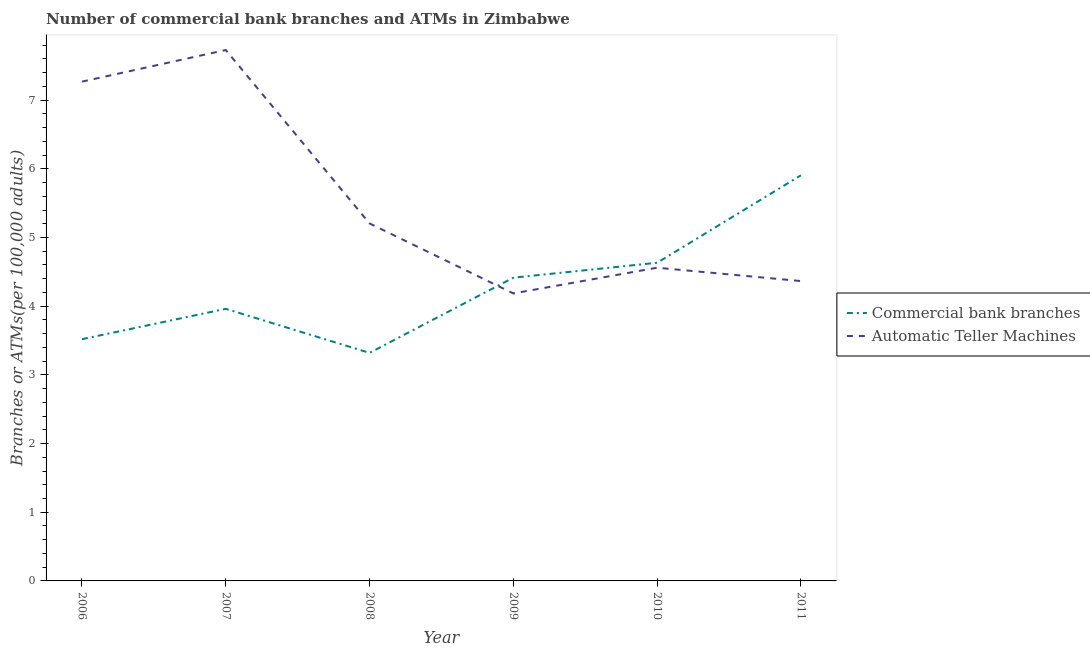How many different coloured lines are there?
Give a very brief answer. 2. Is the number of lines equal to the number of legend labels?
Your answer should be compact. Yes. What is the number of atms in 2009?
Make the answer very short. 4.19. Across all years, what is the maximum number of atms?
Give a very brief answer. 7.73. Across all years, what is the minimum number of commercal bank branches?
Make the answer very short. 3.32. In which year was the number of atms minimum?
Your response must be concise. 2009. What is the total number of commercal bank branches in the graph?
Give a very brief answer. 25.75. What is the difference between the number of atms in 2007 and that in 2011?
Make the answer very short. 3.36. What is the difference between the number of atms in 2011 and the number of commercal bank branches in 2008?
Offer a terse response. 1.05. What is the average number of atms per year?
Provide a short and direct response. 5.55. In the year 2009, what is the difference between the number of commercal bank branches and number of atms?
Keep it short and to the point. 0.23. In how many years, is the number of commercal bank branches greater than 3.8?
Make the answer very short. 4. What is the ratio of the number of atms in 2006 to that in 2008?
Provide a succinct answer. 1.4. Is the number of commercal bank branches in 2008 less than that in 2009?
Offer a terse response. Yes. Is the difference between the number of atms in 2006 and 2011 greater than the difference between the number of commercal bank branches in 2006 and 2011?
Keep it short and to the point. Yes. What is the difference between the highest and the second highest number of atms?
Make the answer very short. 0.46. What is the difference between the highest and the lowest number of commercal bank branches?
Ensure brevity in your answer.  2.59. In how many years, is the number of atms greater than the average number of atms taken over all years?
Make the answer very short. 2. Is the sum of the number of commercal bank branches in 2009 and 2010 greater than the maximum number of atms across all years?
Offer a very short reply. Yes. Does the number of commercal bank branches monotonically increase over the years?
Make the answer very short. No. Is the number of commercal bank branches strictly greater than the number of atms over the years?
Offer a very short reply. No. Is the number of atms strictly less than the number of commercal bank branches over the years?
Offer a very short reply. No. How many years are there in the graph?
Give a very brief answer. 6. What is the difference between two consecutive major ticks on the Y-axis?
Ensure brevity in your answer.  1. Does the graph contain grids?
Your answer should be compact. No. Where does the legend appear in the graph?
Your answer should be very brief. Center right. How many legend labels are there?
Keep it short and to the point. 2. What is the title of the graph?
Your answer should be compact. Number of commercial bank branches and ATMs in Zimbabwe. What is the label or title of the X-axis?
Your answer should be very brief. Year. What is the label or title of the Y-axis?
Your answer should be compact. Branches or ATMs(per 100,0 adults). What is the Branches or ATMs(per 100,000 adults) of Commercial bank branches in 2006?
Ensure brevity in your answer.  3.52. What is the Branches or ATMs(per 100,000 adults) of Automatic Teller Machines in 2006?
Provide a succinct answer. 7.27. What is the Branches or ATMs(per 100,000 adults) of Commercial bank branches in 2007?
Provide a succinct answer. 3.96. What is the Branches or ATMs(per 100,000 adults) in Automatic Teller Machines in 2007?
Your answer should be very brief. 7.73. What is the Branches or ATMs(per 100,000 adults) of Commercial bank branches in 2008?
Offer a terse response. 3.32. What is the Branches or ATMs(per 100,000 adults) of Automatic Teller Machines in 2008?
Ensure brevity in your answer.  5.21. What is the Branches or ATMs(per 100,000 adults) in Commercial bank branches in 2009?
Provide a short and direct response. 4.42. What is the Branches or ATMs(per 100,000 adults) in Automatic Teller Machines in 2009?
Give a very brief answer. 4.19. What is the Branches or ATMs(per 100,000 adults) in Commercial bank branches in 2010?
Your response must be concise. 4.63. What is the Branches or ATMs(per 100,000 adults) of Automatic Teller Machines in 2010?
Provide a succinct answer. 4.56. What is the Branches or ATMs(per 100,000 adults) in Commercial bank branches in 2011?
Provide a succinct answer. 5.91. What is the Branches or ATMs(per 100,000 adults) of Automatic Teller Machines in 2011?
Your response must be concise. 4.37. Across all years, what is the maximum Branches or ATMs(per 100,000 adults) of Commercial bank branches?
Offer a very short reply. 5.91. Across all years, what is the maximum Branches or ATMs(per 100,000 adults) of Automatic Teller Machines?
Offer a very short reply. 7.73. Across all years, what is the minimum Branches or ATMs(per 100,000 adults) in Commercial bank branches?
Offer a terse response. 3.32. Across all years, what is the minimum Branches or ATMs(per 100,000 adults) in Automatic Teller Machines?
Offer a terse response. 4.19. What is the total Branches or ATMs(per 100,000 adults) in Commercial bank branches in the graph?
Provide a short and direct response. 25.75. What is the total Branches or ATMs(per 100,000 adults) of Automatic Teller Machines in the graph?
Your response must be concise. 33.32. What is the difference between the Branches or ATMs(per 100,000 adults) of Commercial bank branches in 2006 and that in 2007?
Provide a short and direct response. -0.44. What is the difference between the Branches or ATMs(per 100,000 adults) of Automatic Teller Machines in 2006 and that in 2007?
Provide a succinct answer. -0.46. What is the difference between the Branches or ATMs(per 100,000 adults) of Commercial bank branches in 2006 and that in 2008?
Keep it short and to the point. 0.2. What is the difference between the Branches or ATMs(per 100,000 adults) of Automatic Teller Machines in 2006 and that in 2008?
Ensure brevity in your answer.  2.06. What is the difference between the Branches or ATMs(per 100,000 adults) in Commercial bank branches in 2006 and that in 2009?
Offer a very short reply. -0.9. What is the difference between the Branches or ATMs(per 100,000 adults) in Automatic Teller Machines in 2006 and that in 2009?
Offer a terse response. 3.08. What is the difference between the Branches or ATMs(per 100,000 adults) of Commercial bank branches in 2006 and that in 2010?
Offer a terse response. -1.11. What is the difference between the Branches or ATMs(per 100,000 adults) in Automatic Teller Machines in 2006 and that in 2010?
Offer a terse response. 2.71. What is the difference between the Branches or ATMs(per 100,000 adults) of Commercial bank branches in 2006 and that in 2011?
Provide a short and direct response. -2.39. What is the difference between the Branches or ATMs(per 100,000 adults) of Automatic Teller Machines in 2006 and that in 2011?
Ensure brevity in your answer.  2.9. What is the difference between the Branches or ATMs(per 100,000 adults) of Commercial bank branches in 2007 and that in 2008?
Offer a terse response. 0.64. What is the difference between the Branches or ATMs(per 100,000 adults) in Automatic Teller Machines in 2007 and that in 2008?
Offer a very short reply. 2.52. What is the difference between the Branches or ATMs(per 100,000 adults) of Commercial bank branches in 2007 and that in 2009?
Your response must be concise. -0.45. What is the difference between the Branches or ATMs(per 100,000 adults) in Automatic Teller Machines in 2007 and that in 2009?
Ensure brevity in your answer.  3.54. What is the difference between the Branches or ATMs(per 100,000 adults) in Commercial bank branches in 2007 and that in 2010?
Provide a succinct answer. -0.67. What is the difference between the Branches or ATMs(per 100,000 adults) in Automatic Teller Machines in 2007 and that in 2010?
Ensure brevity in your answer.  3.17. What is the difference between the Branches or ATMs(per 100,000 adults) of Commercial bank branches in 2007 and that in 2011?
Give a very brief answer. -1.94. What is the difference between the Branches or ATMs(per 100,000 adults) in Automatic Teller Machines in 2007 and that in 2011?
Keep it short and to the point. 3.36. What is the difference between the Branches or ATMs(per 100,000 adults) of Commercial bank branches in 2008 and that in 2009?
Provide a succinct answer. -1.09. What is the difference between the Branches or ATMs(per 100,000 adults) in Automatic Teller Machines in 2008 and that in 2009?
Offer a very short reply. 1.02. What is the difference between the Branches or ATMs(per 100,000 adults) of Commercial bank branches in 2008 and that in 2010?
Give a very brief answer. -1.31. What is the difference between the Branches or ATMs(per 100,000 adults) in Automatic Teller Machines in 2008 and that in 2010?
Keep it short and to the point. 0.64. What is the difference between the Branches or ATMs(per 100,000 adults) in Commercial bank branches in 2008 and that in 2011?
Provide a short and direct response. -2.59. What is the difference between the Branches or ATMs(per 100,000 adults) of Automatic Teller Machines in 2008 and that in 2011?
Offer a very short reply. 0.84. What is the difference between the Branches or ATMs(per 100,000 adults) in Commercial bank branches in 2009 and that in 2010?
Offer a terse response. -0.22. What is the difference between the Branches or ATMs(per 100,000 adults) in Automatic Teller Machines in 2009 and that in 2010?
Offer a terse response. -0.37. What is the difference between the Branches or ATMs(per 100,000 adults) of Commercial bank branches in 2009 and that in 2011?
Offer a very short reply. -1.49. What is the difference between the Branches or ATMs(per 100,000 adults) of Automatic Teller Machines in 2009 and that in 2011?
Provide a succinct answer. -0.18. What is the difference between the Branches or ATMs(per 100,000 adults) of Commercial bank branches in 2010 and that in 2011?
Your answer should be very brief. -1.27. What is the difference between the Branches or ATMs(per 100,000 adults) of Automatic Teller Machines in 2010 and that in 2011?
Your answer should be very brief. 0.19. What is the difference between the Branches or ATMs(per 100,000 adults) in Commercial bank branches in 2006 and the Branches or ATMs(per 100,000 adults) in Automatic Teller Machines in 2007?
Give a very brief answer. -4.21. What is the difference between the Branches or ATMs(per 100,000 adults) of Commercial bank branches in 2006 and the Branches or ATMs(per 100,000 adults) of Automatic Teller Machines in 2008?
Give a very brief answer. -1.69. What is the difference between the Branches or ATMs(per 100,000 adults) of Commercial bank branches in 2006 and the Branches or ATMs(per 100,000 adults) of Automatic Teller Machines in 2009?
Provide a short and direct response. -0.67. What is the difference between the Branches or ATMs(per 100,000 adults) of Commercial bank branches in 2006 and the Branches or ATMs(per 100,000 adults) of Automatic Teller Machines in 2010?
Offer a very short reply. -1.04. What is the difference between the Branches or ATMs(per 100,000 adults) of Commercial bank branches in 2006 and the Branches or ATMs(per 100,000 adults) of Automatic Teller Machines in 2011?
Provide a short and direct response. -0.85. What is the difference between the Branches or ATMs(per 100,000 adults) of Commercial bank branches in 2007 and the Branches or ATMs(per 100,000 adults) of Automatic Teller Machines in 2008?
Your answer should be very brief. -1.24. What is the difference between the Branches or ATMs(per 100,000 adults) in Commercial bank branches in 2007 and the Branches or ATMs(per 100,000 adults) in Automatic Teller Machines in 2009?
Keep it short and to the point. -0.22. What is the difference between the Branches or ATMs(per 100,000 adults) in Commercial bank branches in 2007 and the Branches or ATMs(per 100,000 adults) in Automatic Teller Machines in 2010?
Ensure brevity in your answer.  -0.6. What is the difference between the Branches or ATMs(per 100,000 adults) in Commercial bank branches in 2007 and the Branches or ATMs(per 100,000 adults) in Automatic Teller Machines in 2011?
Offer a very short reply. -0.4. What is the difference between the Branches or ATMs(per 100,000 adults) in Commercial bank branches in 2008 and the Branches or ATMs(per 100,000 adults) in Automatic Teller Machines in 2009?
Your answer should be very brief. -0.87. What is the difference between the Branches or ATMs(per 100,000 adults) in Commercial bank branches in 2008 and the Branches or ATMs(per 100,000 adults) in Automatic Teller Machines in 2010?
Your response must be concise. -1.24. What is the difference between the Branches or ATMs(per 100,000 adults) of Commercial bank branches in 2008 and the Branches or ATMs(per 100,000 adults) of Automatic Teller Machines in 2011?
Provide a short and direct response. -1.05. What is the difference between the Branches or ATMs(per 100,000 adults) in Commercial bank branches in 2009 and the Branches or ATMs(per 100,000 adults) in Automatic Teller Machines in 2010?
Your answer should be very brief. -0.15. What is the difference between the Branches or ATMs(per 100,000 adults) of Commercial bank branches in 2009 and the Branches or ATMs(per 100,000 adults) of Automatic Teller Machines in 2011?
Offer a very short reply. 0.05. What is the difference between the Branches or ATMs(per 100,000 adults) of Commercial bank branches in 2010 and the Branches or ATMs(per 100,000 adults) of Automatic Teller Machines in 2011?
Your answer should be compact. 0.27. What is the average Branches or ATMs(per 100,000 adults) in Commercial bank branches per year?
Ensure brevity in your answer.  4.29. What is the average Branches or ATMs(per 100,000 adults) of Automatic Teller Machines per year?
Provide a succinct answer. 5.55. In the year 2006, what is the difference between the Branches or ATMs(per 100,000 adults) in Commercial bank branches and Branches or ATMs(per 100,000 adults) in Automatic Teller Machines?
Offer a terse response. -3.75. In the year 2007, what is the difference between the Branches or ATMs(per 100,000 adults) of Commercial bank branches and Branches or ATMs(per 100,000 adults) of Automatic Teller Machines?
Your answer should be compact. -3.77. In the year 2008, what is the difference between the Branches or ATMs(per 100,000 adults) of Commercial bank branches and Branches or ATMs(per 100,000 adults) of Automatic Teller Machines?
Provide a short and direct response. -1.88. In the year 2009, what is the difference between the Branches or ATMs(per 100,000 adults) in Commercial bank branches and Branches or ATMs(per 100,000 adults) in Automatic Teller Machines?
Offer a terse response. 0.23. In the year 2010, what is the difference between the Branches or ATMs(per 100,000 adults) of Commercial bank branches and Branches or ATMs(per 100,000 adults) of Automatic Teller Machines?
Offer a very short reply. 0.07. In the year 2011, what is the difference between the Branches or ATMs(per 100,000 adults) of Commercial bank branches and Branches or ATMs(per 100,000 adults) of Automatic Teller Machines?
Make the answer very short. 1.54. What is the ratio of the Branches or ATMs(per 100,000 adults) in Commercial bank branches in 2006 to that in 2007?
Provide a short and direct response. 0.89. What is the ratio of the Branches or ATMs(per 100,000 adults) in Automatic Teller Machines in 2006 to that in 2007?
Make the answer very short. 0.94. What is the ratio of the Branches or ATMs(per 100,000 adults) of Commercial bank branches in 2006 to that in 2008?
Ensure brevity in your answer.  1.06. What is the ratio of the Branches or ATMs(per 100,000 adults) of Automatic Teller Machines in 2006 to that in 2008?
Your answer should be compact. 1.4. What is the ratio of the Branches or ATMs(per 100,000 adults) in Commercial bank branches in 2006 to that in 2009?
Keep it short and to the point. 0.8. What is the ratio of the Branches or ATMs(per 100,000 adults) in Automatic Teller Machines in 2006 to that in 2009?
Ensure brevity in your answer.  1.74. What is the ratio of the Branches or ATMs(per 100,000 adults) in Commercial bank branches in 2006 to that in 2010?
Make the answer very short. 0.76. What is the ratio of the Branches or ATMs(per 100,000 adults) in Automatic Teller Machines in 2006 to that in 2010?
Your answer should be compact. 1.59. What is the ratio of the Branches or ATMs(per 100,000 adults) of Commercial bank branches in 2006 to that in 2011?
Provide a succinct answer. 0.6. What is the ratio of the Branches or ATMs(per 100,000 adults) in Automatic Teller Machines in 2006 to that in 2011?
Your response must be concise. 1.67. What is the ratio of the Branches or ATMs(per 100,000 adults) in Commercial bank branches in 2007 to that in 2008?
Offer a very short reply. 1.19. What is the ratio of the Branches or ATMs(per 100,000 adults) of Automatic Teller Machines in 2007 to that in 2008?
Ensure brevity in your answer.  1.49. What is the ratio of the Branches or ATMs(per 100,000 adults) in Commercial bank branches in 2007 to that in 2009?
Your answer should be compact. 0.9. What is the ratio of the Branches or ATMs(per 100,000 adults) in Automatic Teller Machines in 2007 to that in 2009?
Offer a terse response. 1.85. What is the ratio of the Branches or ATMs(per 100,000 adults) of Commercial bank branches in 2007 to that in 2010?
Provide a succinct answer. 0.86. What is the ratio of the Branches or ATMs(per 100,000 adults) in Automatic Teller Machines in 2007 to that in 2010?
Make the answer very short. 1.7. What is the ratio of the Branches or ATMs(per 100,000 adults) of Commercial bank branches in 2007 to that in 2011?
Your response must be concise. 0.67. What is the ratio of the Branches or ATMs(per 100,000 adults) in Automatic Teller Machines in 2007 to that in 2011?
Offer a very short reply. 1.77. What is the ratio of the Branches or ATMs(per 100,000 adults) of Commercial bank branches in 2008 to that in 2009?
Your answer should be very brief. 0.75. What is the ratio of the Branches or ATMs(per 100,000 adults) in Automatic Teller Machines in 2008 to that in 2009?
Ensure brevity in your answer.  1.24. What is the ratio of the Branches or ATMs(per 100,000 adults) in Commercial bank branches in 2008 to that in 2010?
Your response must be concise. 0.72. What is the ratio of the Branches or ATMs(per 100,000 adults) in Automatic Teller Machines in 2008 to that in 2010?
Keep it short and to the point. 1.14. What is the ratio of the Branches or ATMs(per 100,000 adults) of Commercial bank branches in 2008 to that in 2011?
Provide a succinct answer. 0.56. What is the ratio of the Branches or ATMs(per 100,000 adults) in Automatic Teller Machines in 2008 to that in 2011?
Your answer should be compact. 1.19. What is the ratio of the Branches or ATMs(per 100,000 adults) in Commercial bank branches in 2009 to that in 2010?
Make the answer very short. 0.95. What is the ratio of the Branches or ATMs(per 100,000 adults) in Automatic Teller Machines in 2009 to that in 2010?
Your response must be concise. 0.92. What is the ratio of the Branches or ATMs(per 100,000 adults) of Commercial bank branches in 2009 to that in 2011?
Ensure brevity in your answer.  0.75. What is the ratio of the Branches or ATMs(per 100,000 adults) in Automatic Teller Machines in 2009 to that in 2011?
Your response must be concise. 0.96. What is the ratio of the Branches or ATMs(per 100,000 adults) in Commercial bank branches in 2010 to that in 2011?
Keep it short and to the point. 0.78. What is the ratio of the Branches or ATMs(per 100,000 adults) in Automatic Teller Machines in 2010 to that in 2011?
Offer a very short reply. 1.04. What is the difference between the highest and the second highest Branches or ATMs(per 100,000 adults) of Commercial bank branches?
Your answer should be very brief. 1.27. What is the difference between the highest and the second highest Branches or ATMs(per 100,000 adults) in Automatic Teller Machines?
Your answer should be very brief. 0.46. What is the difference between the highest and the lowest Branches or ATMs(per 100,000 adults) of Commercial bank branches?
Make the answer very short. 2.59. What is the difference between the highest and the lowest Branches or ATMs(per 100,000 adults) of Automatic Teller Machines?
Your answer should be very brief. 3.54. 